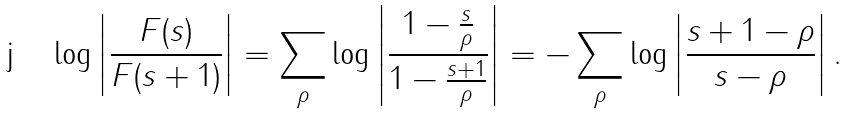<formula> <loc_0><loc_0><loc_500><loc_500>\log \left | \frac { F ( s ) } { F ( s + 1 ) } \right | = \sum _ { \rho } \log \left | \frac { 1 - \frac { s } { \rho } } { 1 - \frac { s + 1 } { \rho } } \right | = - \sum _ { \rho } \log \left | \frac { s + 1 - \rho } { s - \rho } \right | .</formula> 